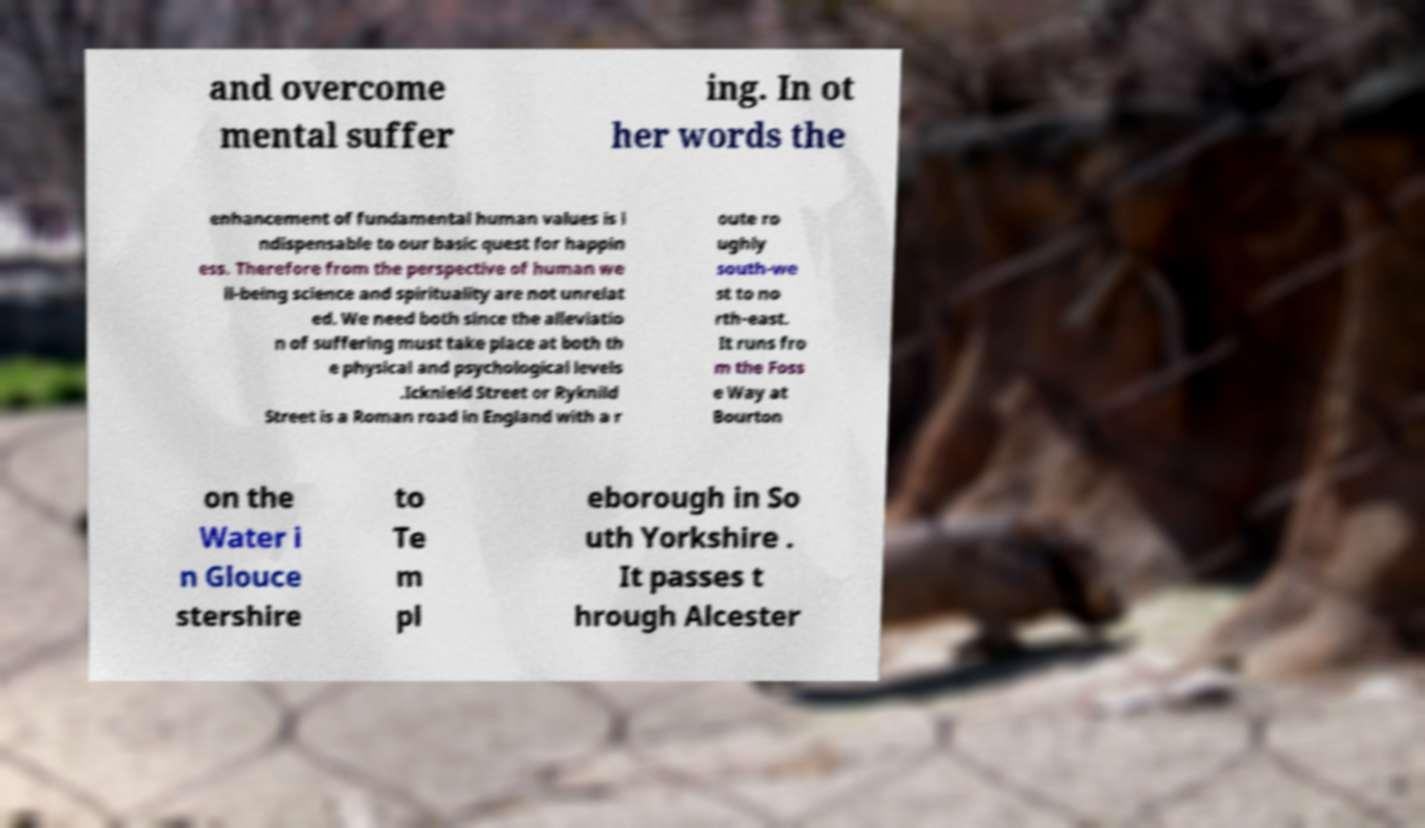There's text embedded in this image that I need extracted. Can you transcribe it verbatim? and overcome mental suffer ing. In ot her words the enhancement of fundamental human values is i ndispensable to our basic quest for happin ess. Therefore from the perspective of human we ll-being science and spirituality are not unrelat ed. We need both since the alleviatio n of suffering must take place at both th e physical and psychological levels .Icknield Street or Ryknild Street is a Roman road in England with a r oute ro ughly south-we st to no rth-east. It runs fro m the Foss e Way at Bourton on the Water i n Glouce stershire to Te m pl eborough in So uth Yorkshire . It passes t hrough Alcester 